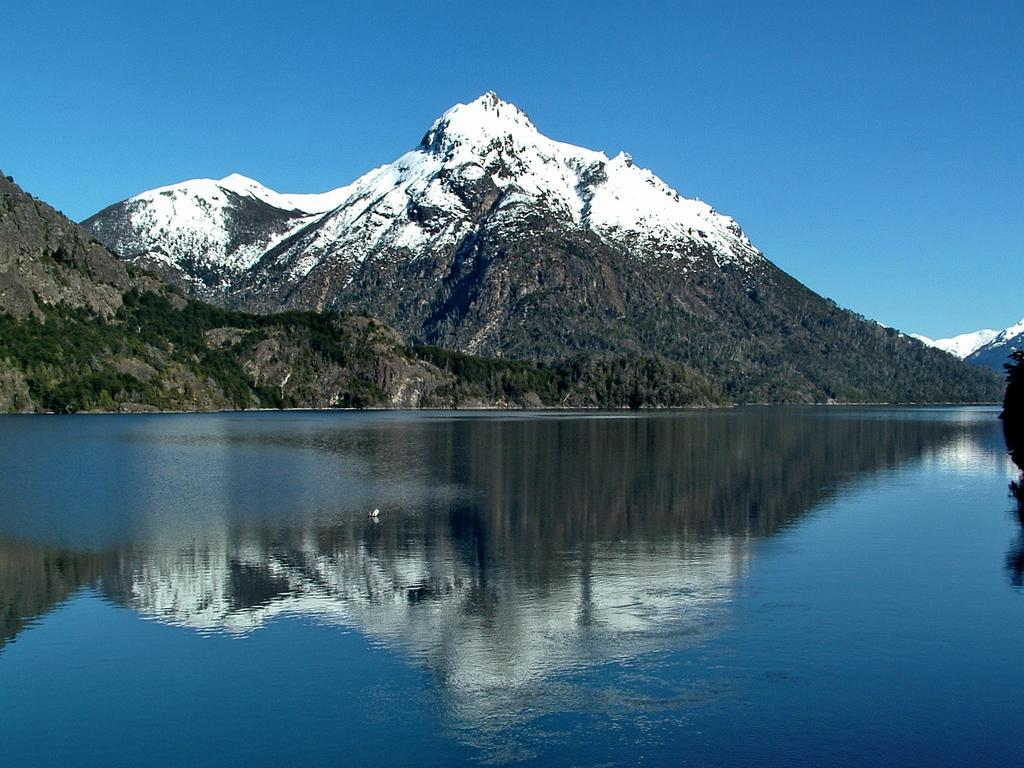What is visible in the image? Water is visible in the image. What can be seen in the background of the image? There is a hill with trees in the background of the image. What is covering the hill? There is snow on the hill. What is visible at the top of the image? The sky is visible at the top of the image. What type of ticket is required to access the route shown in the image? There is no route or ticket present in the image; it only shows water, a hill with trees, snow, and the sky. 